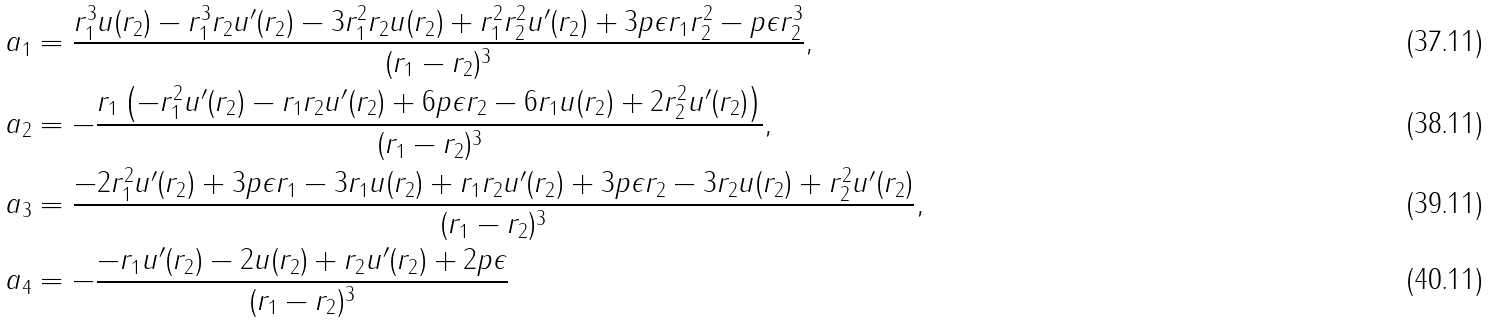Convert formula to latex. <formula><loc_0><loc_0><loc_500><loc_500>a _ { 1 } & = \frac { r _ { 1 } ^ { 3 } u ( r _ { 2 } ) - r _ { 1 } ^ { 3 } r _ { 2 } u ^ { \prime } ( r _ { 2 } ) - 3 r _ { 1 } ^ { 2 } r _ { 2 } u ( r _ { 2 } ) + r _ { 1 } ^ { 2 } r _ { 2 } ^ { 2 } u ^ { \prime } ( r _ { 2 } ) + 3 p \epsilon r _ { 1 } r _ { 2 } ^ { 2 } - p \epsilon r _ { 2 } ^ { 3 } } { ( r _ { 1 } - r _ { 2 } ) ^ { 3 } } , \\ a _ { 2 } & = - \frac { r _ { 1 } \left ( - r _ { 1 } ^ { 2 } u ^ { \prime } ( r _ { 2 } ) - r _ { 1 } r _ { 2 } u ^ { \prime } ( r _ { 2 } ) + 6 p \epsilon r _ { 2 } - 6 r _ { 1 } u ( r _ { 2 } ) + 2 r _ { 2 } ^ { 2 } u ^ { \prime } ( r _ { 2 } ) \right ) } { ( r _ { 1 } - r _ { 2 } ) ^ { 3 } } , \\ a _ { 3 } & = \frac { - 2 r _ { 1 } ^ { 2 } u ^ { \prime } ( r _ { 2 } ) + 3 p \epsilon r _ { 1 } - 3 r _ { 1 } u ( r _ { 2 } ) + r _ { 1 } r _ { 2 } u ^ { \prime } ( r _ { 2 } ) + 3 p \epsilon r _ { 2 } - 3 r _ { 2 } u ( r _ { 2 } ) + r _ { 2 } ^ { 2 } u ^ { \prime } ( r _ { 2 } ) } { ( r _ { 1 } - r _ { 2 } ) ^ { 3 } } , \\ a _ { 4 } & = - \frac { - r _ { 1 } u ^ { \prime } ( r _ { 2 } ) - 2 u ( r _ { 2 } ) + r _ { 2 } u ^ { \prime } ( r _ { 2 } ) + 2 p \epsilon } { ( r _ { 1 } - r _ { 2 } ) ^ { 3 } }</formula> 